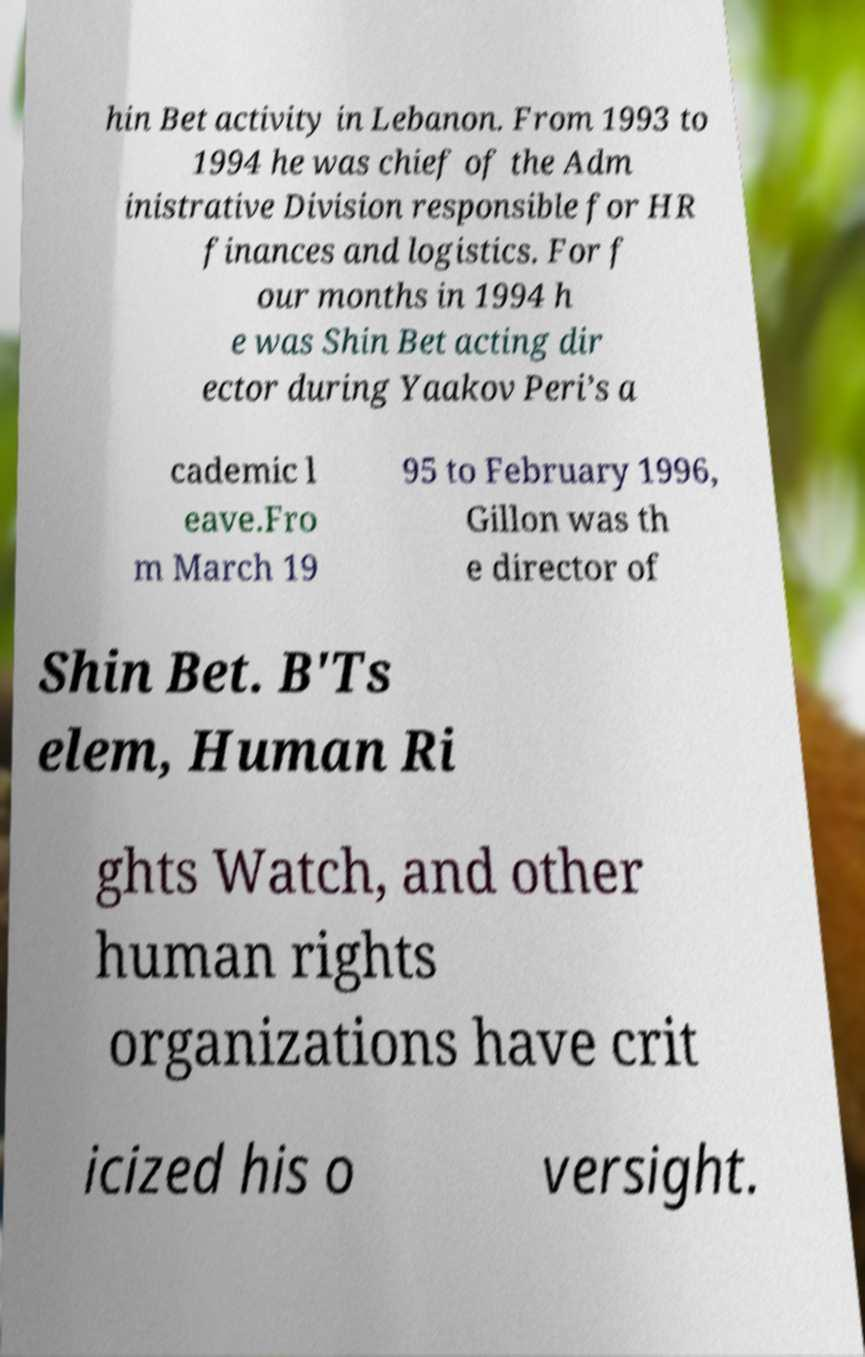Could you extract and type out the text from this image? hin Bet activity in Lebanon. From 1993 to 1994 he was chief of the Adm inistrative Division responsible for HR finances and logistics. For f our months in 1994 h e was Shin Bet acting dir ector during Yaakov Peri’s a cademic l eave.Fro m March 19 95 to February 1996, Gillon was th e director of Shin Bet. B'Ts elem, Human Ri ghts Watch, and other human rights organizations have crit icized his o versight. 